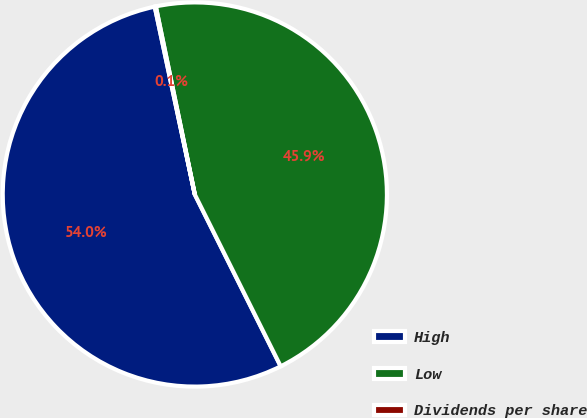Convert chart. <chart><loc_0><loc_0><loc_500><loc_500><pie_chart><fcel>High<fcel>Low<fcel>Dividends per share<nl><fcel>54.03%<fcel>45.88%<fcel>0.09%<nl></chart> 